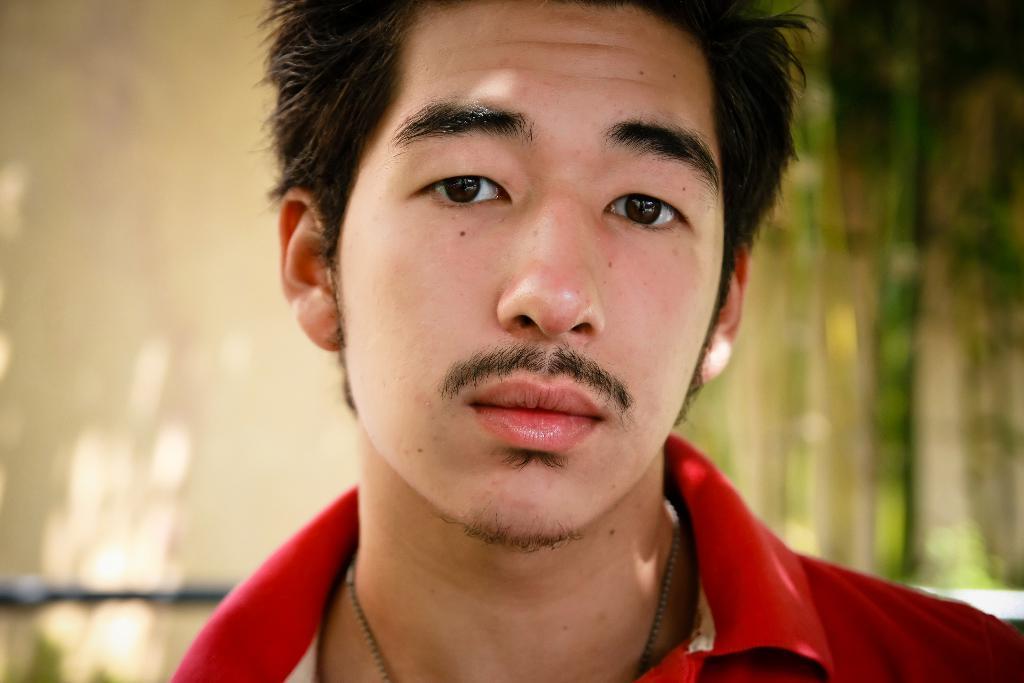In one or two sentences, can you explain what this image depicts? In the middle of the image we can see a man, he wore a red color t-shirt, and we can see few trees in the background. 